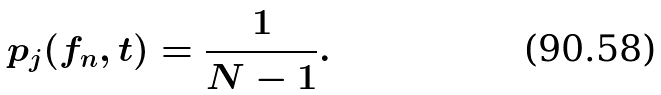Convert formula to latex. <formula><loc_0><loc_0><loc_500><loc_500>p _ { j } ( f _ { n } , t ) = \frac { 1 } { N - 1 } .</formula> 